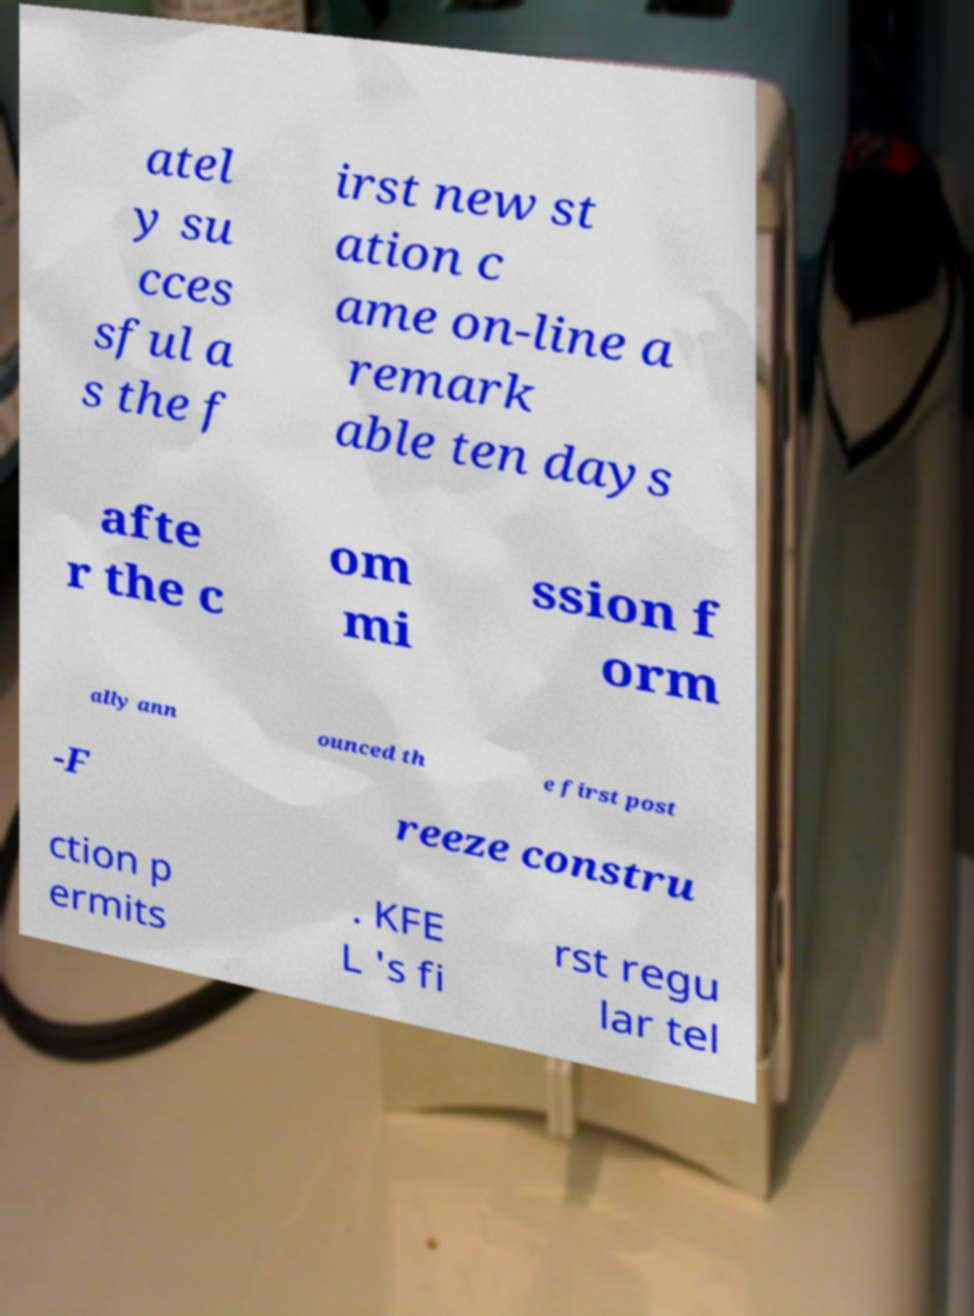Please identify and transcribe the text found in this image. atel y su cces sful a s the f irst new st ation c ame on-line a remark able ten days afte r the c om mi ssion f orm ally ann ounced th e first post -F reeze constru ction p ermits . KFE L 's fi rst regu lar tel 